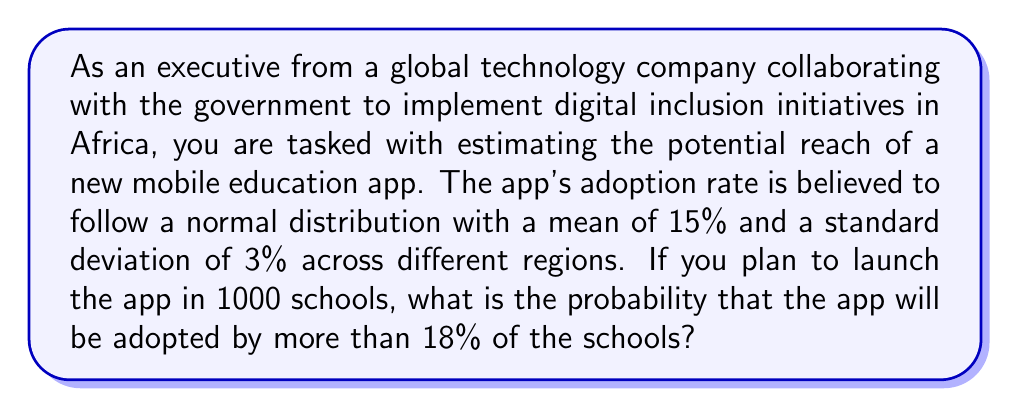Solve this math problem. To solve this problem, we need to use the properties of the normal distribution and the concept of z-scores.

1. Given information:
   - The adoption rate follows a normal distribution
   - Mean (μ) = 15%
   - Standard deviation (σ) = 3%
   - We want to find P(X > 18%), where X is the adoption rate

2. Calculate the z-score for 18%:
   $$ z = \frac{x - μ}{σ} = \frac{18 - 15}{3} = 1 $$

3. Use the standard normal distribution table or a calculator to find the area to the right of z = 1:
   P(Z > 1) = 1 - P(Z < 1) = 1 - 0.8413 = 0.1587

4. Therefore, the probability that the app will be adopted by more than 18% of the schools is approximately 0.1587 or 15.87%.

This calculation gives us the probability for a single school. However, since we're launching the app in 1000 schools, we can interpret this result as the expected proportion of schools that will have an adoption rate higher than 18%.
Answer: The probability that the mobile education app will be adopted by more than 18% of the schools is approximately 0.1587 or 15.87%. 